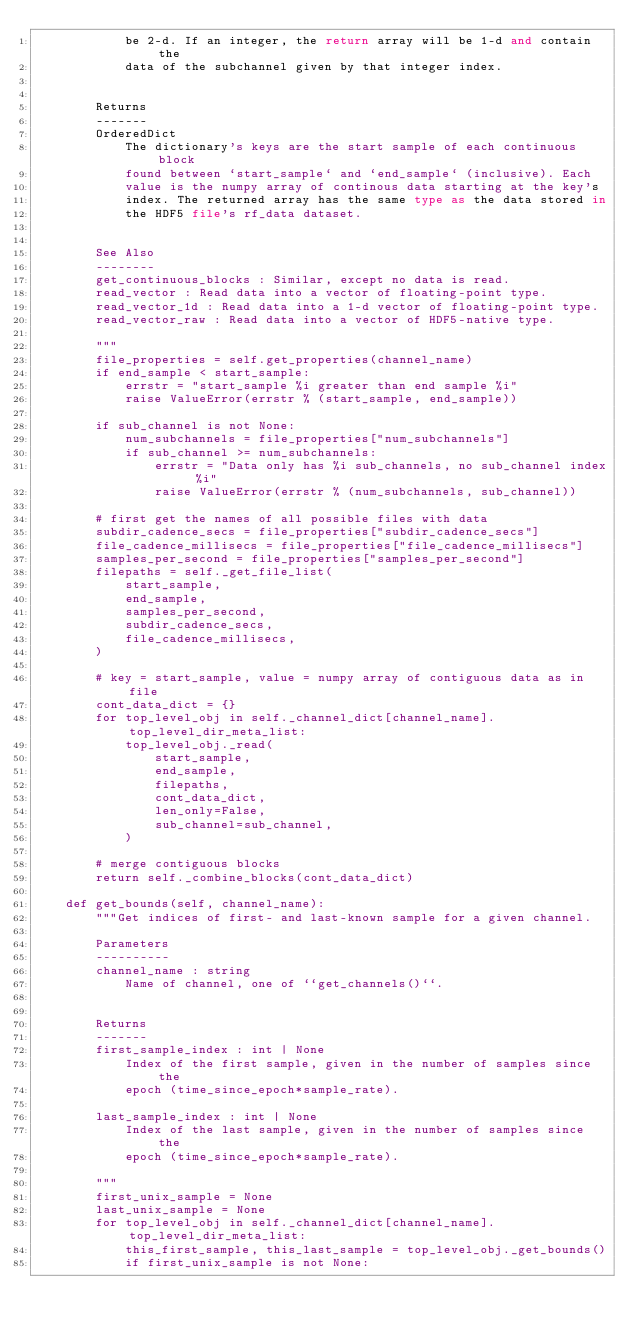<code> <loc_0><loc_0><loc_500><loc_500><_Python_>            be 2-d. If an integer, the return array will be 1-d and contain the
            data of the subchannel given by that integer index.


        Returns
        -------
        OrderedDict
            The dictionary's keys are the start sample of each continuous block
            found between `start_sample` and `end_sample` (inclusive). Each
            value is the numpy array of continous data starting at the key's
            index. The returned array has the same type as the data stored in
            the HDF5 file's rf_data dataset.


        See Also
        --------
        get_continuous_blocks : Similar, except no data is read.
        read_vector : Read data into a vector of floating-point type.
        read_vector_1d : Read data into a 1-d vector of floating-point type.
        read_vector_raw : Read data into a vector of HDF5-native type.

        """
        file_properties = self.get_properties(channel_name)
        if end_sample < start_sample:
            errstr = "start_sample %i greater than end sample %i"
            raise ValueError(errstr % (start_sample, end_sample))

        if sub_channel is not None:
            num_subchannels = file_properties["num_subchannels"]
            if sub_channel >= num_subchannels:
                errstr = "Data only has %i sub_channels, no sub_channel index %i"
                raise ValueError(errstr % (num_subchannels, sub_channel))

        # first get the names of all possible files with data
        subdir_cadence_secs = file_properties["subdir_cadence_secs"]
        file_cadence_millisecs = file_properties["file_cadence_millisecs"]
        samples_per_second = file_properties["samples_per_second"]
        filepaths = self._get_file_list(
            start_sample,
            end_sample,
            samples_per_second,
            subdir_cadence_secs,
            file_cadence_millisecs,
        )

        # key = start_sample, value = numpy array of contiguous data as in file
        cont_data_dict = {}
        for top_level_obj in self._channel_dict[channel_name].top_level_dir_meta_list:
            top_level_obj._read(
                start_sample,
                end_sample,
                filepaths,
                cont_data_dict,
                len_only=False,
                sub_channel=sub_channel,
            )

        # merge contiguous blocks
        return self._combine_blocks(cont_data_dict)

    def get_bounds(self, channel_name):
        """Get indices of first- and last-known sample for a given channel.

        Parameters
        ----------
        channel_name : string
            Name of channel, one of ``get_channels()``.


        Returns
        -------
        first_sample_index : int | None
            Index of the first sample, given in the number of samples since the
            epoch (time_since_epoch*sample_rate).

        last_sample_index : int | None
            Index of the last sample, given in the number of samples since the
            epoch (time_since_epoch*sample_rate).

        """
        first_unix_sample = None
        last_unix_sample = None
        for top_level_obj in self._channel_dict[channel_name].top_level_dir_meta_list:
            this_first_sample, this_last_sample = top_level_obj._get_bounds()
            if first_unix_sample is not None:</code> 